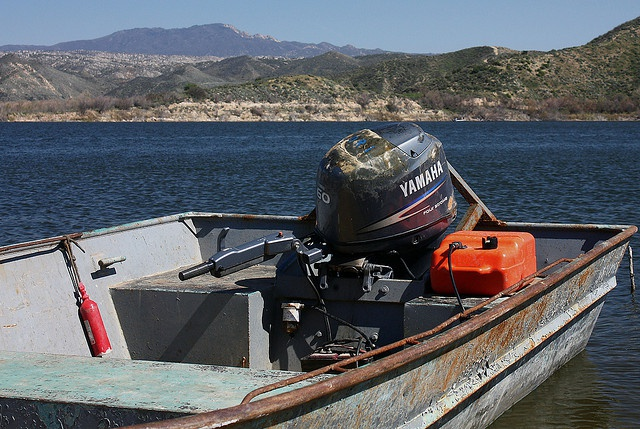Describe the objects in this image and their specific colors. I can see a boat in darkgray, black, gray, and lightgray tones in this image. 